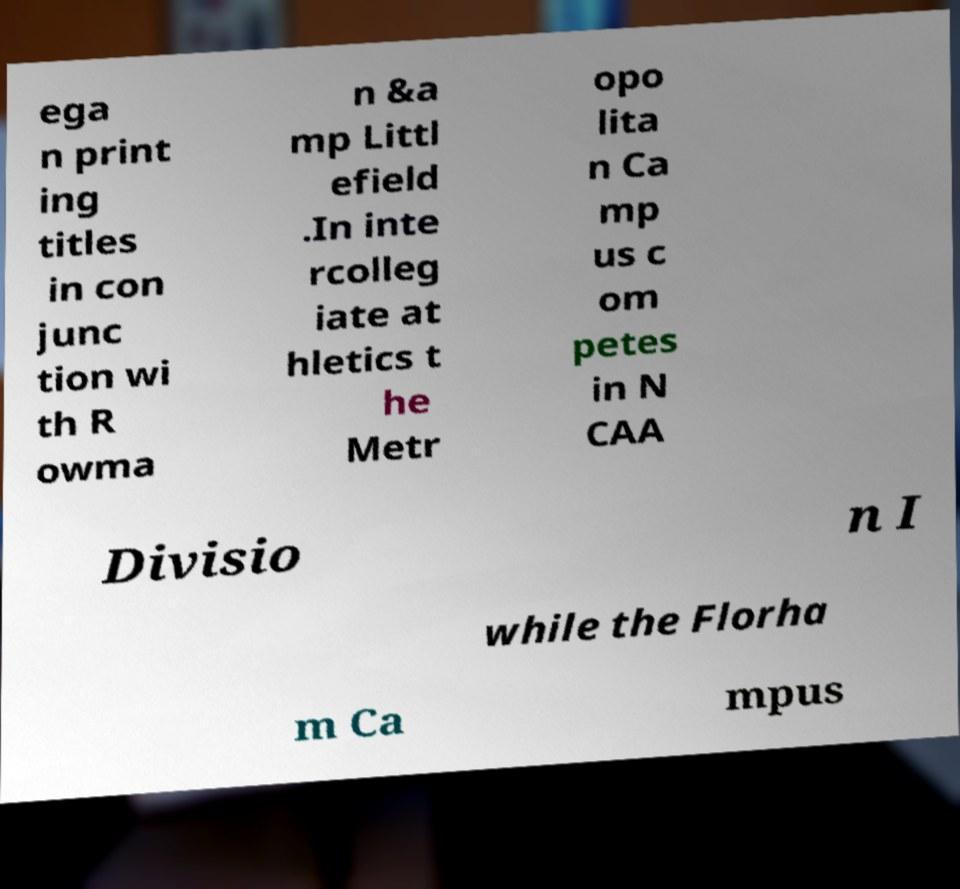Please read and relay the text visible in this image. What does it say? ega n print ing titles in con junc tion wi th R owma n &a mp Littl efield .In inte rcolleg iate at hletics t he Metr opo lita n Ca mp us c om petes in N CAA Divisio n I while the Florha m Ca mpus 